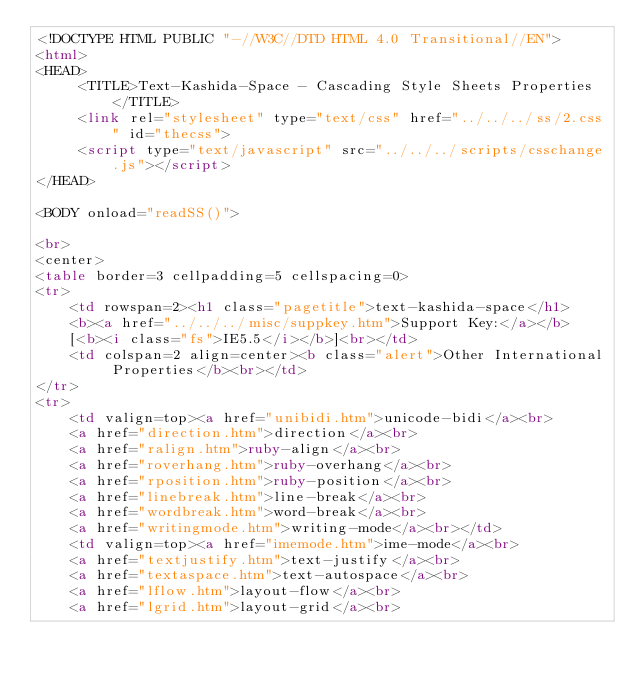<code> <loc_0><loc_0><loc_500><loc_500><_HTML_><!DOCTYPE HTML PUBLIC "-//W3C//DTD HTML 4.0 Transitional//EN">
<html>
<HEAD>
     <TITLE>Text-Kashida-Space - Cascading Style Sheets Properties</TITLE>
     <link rel="stylesheet" type="text/css" href="../../../ss/2.css" id="thecss">
     <script type="text/javascript" src="../../../scripts/csschange.js"></script>
</HEAD>

<BODY onload="readSS()">

<br>
<center>
<table border=3 cellpadding=5 cellspacing=0>
<tr>
    <td rowspan=2><h1 class="pagetitle">text-kashida-space</h1>
    <b><a href="../../../misc/suppkey.htm">Support Key:</a></b>
    [<b><i class="fs">IE5.5</i></b>]<br></td>
    <td colspan=2 align=center><b class="alert">Other International Properties</b><br></td>
</tr>
<tr>
    <td valign=top><a href="unibidi.htm">unicode-bidi</a><br>
    <a href="direction.htm">direction</a><br>
    <a href="ralign.htm">ruby-align</a><br>
    <a href="roverhang.htm">ruby-overhang</a><br>
    <a href="rposition.htm">ruby-position</a><br>
    <a href="linebreak.htm">line-break</a><br>
    <a href="wordbreak.htm">word-break</a><br>
    <a href="writingmode.htm">writing-mode</a><br></td>
    <td valign=top><a href="imemode.htm">ime-mode</a><br>
    <a href="textjustify.htm">text-justify</a><br>
    <a href="textaspace.htm">text-autospace</a><br>
    <a href="lflow.htm">layout-flow</a><br>
    <a href="lgrid.htm">layout-grid</a><br></code> 